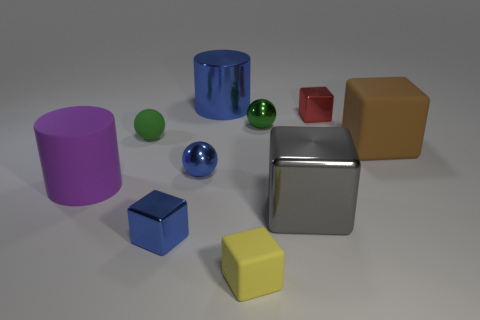Subtract all yellow rubber cubes. How many cubes are left? 4 Subtract all red blocks. How many blocks are left? 4 Subtract all cyan blocks. Subtract all red cylinders. How many blocks are left? 5 Subtract all spheres. How many objects are left? 7 Add 5 tiny rubber things. How many tiny rubber things are left? 7 Add 3 big blue metal objects. How many big blue metal objects exist? 4 Subtract 0 green cylinders. How many objects are left? 10 Subtract all small metal blocks. Subtract all blue metal balls. How many objects are left? 7 